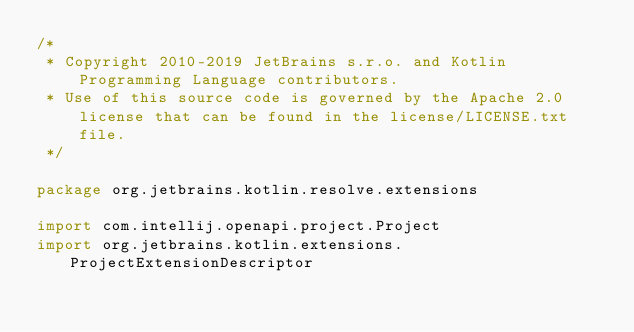Convert code to text. <code><loc_0><loc_0><loc_500><loc_500><_Kotlin_>/*
 * Copyright 2010-2019 JetBrains s.r.o. and Kotlin Programming Language contributors.
 * Use of this source code is governed by the Apache 2.0 license that can be found in the license/LICENSE.txt file.
 */

package org.jetbrains.kotlin.resolve.extensions

import com.intellij.openapi.project.Project
import org.jetbrains.kotlin.extensions.ProjectExtensionDescriptor</code> 